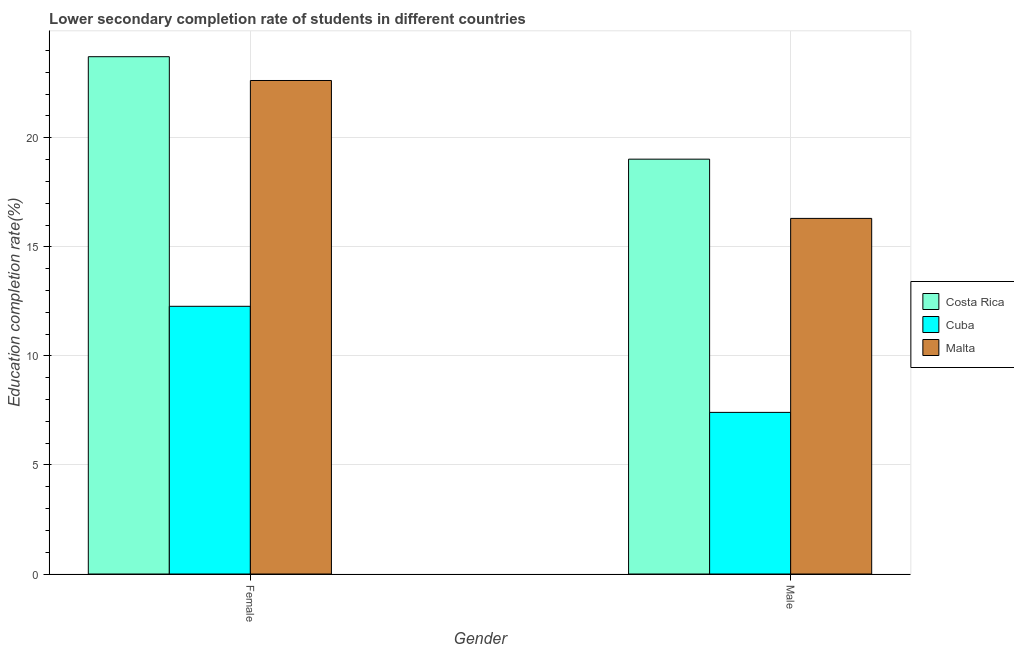Are the number of bars on each tick of the X-axis equal?
Give a very brief answer. Yes. How many bars are there on the 2nd tick from the left?
Provide a short and direct response. 3. How many bars are there on the 1st tick from the right?
Your answer should be very brief. 3. What is the education completion rate of female students in Malta?
Your answer should be compact. 22.63. Across all countries, what is the maximum education completion rate of female students?
Ensure brevity in your answer.  23.72. Across all countries, what is the minimum education completion rate of female students?
Give a very brief answer. 12.27. In which country was the education completion rate of female students minimum?
Your response must be concise. Cuba. What is the total education completion rate of female students in the graph?
Provide a short and direct response. 58.61. What is the difference between the education completion rate of male students in Malta and that in Cuba?
Provide a short and direct response. 8.89. What is the difference between the education completion rate of female students in Cuba and the education completion rate of male students in Malta?
Offer a very short reply. -4.03. What is the average education completion rate of male students per country?
Your answer should be very brief. 14.24. What is the difference between the education completion rate of male students and education completion rate of female students in Malta?
Ensure brevity in your answer.  -6.32. In how many countries, is the education completion rate of female students greater than 19 %?
Offer a very short reply. 2. What is the ratio of the education completion rate of male students in Malta to that in Cuba?
Offer a very short reply. 2.2. Is the education completion rate of female students in Malta less than that in Costa Rica?
Your answer should be compact. Yes. In how many countries, is the education completion rate of female students greater than the average education completion rate of female students taken over all countries?
Make the answer very short. 2. What does the 2nd bar from the right in Female represents?
Provide a short and direct response. Cuba. Are all the bars in the graph horizontal?
Make the answer very short. No. How many countries are there in the graph?
Ensure brevity in your answer.  3. What is the difference between two consecutive major ticks on the Y-axis?
Make the answer very short. 5. Does the graph contain grids?
Give a very brief answer. Yes. Where does the legend appear in the graph?
Your response must be concise. Center right. How are the legend labels stacked?
Provide a succinct answer. Vertical. What is the title of the graph?
Your answer should be compact. Lower secondary completion rate of students in different countries. What is the label or title of the X-axis?
Offer a very short reply. Gender. What is the label or title of the Y-axis?
Give a very brief answer. Education completion rate(%). What is the Education completion rate(%) of Costa Rica in Female?
Keep it short and to the point. 23.72. What is the Education completion rate(%) of Cuba in Female?
Your answer should be very brief. 12.27. What is the Education completion rate(%) of Malta in Female?
Provide a succinct answer. 22.63. What is the Education completion rate(%) in Costa Rica in Male?
Your answer should be very brief. 19.02. What is the Education completion rate(%) in Cuba in Male?
Your response must be concise. 7.41. What is the Education completion rate(%) of Malta in Male?
Ensure brevity in your answer.  16.3. Across all Gender, what is the maximum Education completion rate(%) of Costa Rica?
Keep it short and to the point. 23.72. Across all Gender, what is the maximum Education completion rate(%) in Cuba?
Your response must be concise. 12.27. Across all Gender, what is the maximum Education completion rate(%) of Malta?
Ensure brevity in your answer.  22.63. Across all Gender, what is the minimum Education completion rate(%) in Costa Rica?
Make the answer very short. 19.02. Across all Gender, what is the minimum Education completion rate(%) in Cuba?
Provide a short and direct response. 7.41. Across all Gender, what is the minimum Education completion rate(%) of Malta?
Provide a succinct answer. 16.3. What is the total Education completion rate(%) of Costa Rica in the graph?
Provide a short and direct response. 42.73. What is the total Education completion rate(%) in Cuba in the graph?
Keep it short and to the point. 19.68. What is the total Education completion rate(%) in Malta in the graph?
Your answer should be compact. 38.93. What is the difference between the Education completion rate(%) in Costa Rica in Female and that in Male?
Offer a very short reply. 4.7. What is the difference between the Education completion rate(%) of Cuba in Female and that in Male?
Your answer should be compact. 4.86. What is the difference between the Education completion rate(%) in Malta in Female and that in Male?
Your answer should be very brief. 6.32. What is the difference between the Education completion rate(%) of Costa Rica in Female and the Education completion rate(%) of Cuba in Male?
Offer a very short reply. 16.31. What is the difference between the Education completion rate(%) of Costa Rica in Female and the Education completion rate(%) of Malta in Male?
Your response must be concise. 7.41. What is the difference between the Education completion rate(%) of Cuba in Female and the Education completion rate(%) of Malta in Male?
Provide a succinct answer. -4.03. What is the average Education completion rate(%) of Costa Rica per Gender?
Provide a succinct answer. 21.37. What is the average Education completion rate(%) of Cuba per Gender?
Make the answer very short. 9.84. What is the average Education completion rate(%) in Malta per Gender?
Your answer should be very brief. 19.46. What is the difference between the Education completion rate(%) in Costa Rica and Education completion rate(%) in Cuba in Female?
Offer a very short reply. 11.44. What is the difference between the Education completion rate(%) of Costa Rica and Education completion rate(%) of Malta in Female?
Your answer should be compact. 1.09. What is the difference between the Education completion rate(%) of Cuba and Education completion rate(%) of Malta in Female?
Keep it short and to the point. -10.35. What is the difference between the Education completion rate(%) in Costa Rica and Education completion rate(%) in Cuba in Male?
Provide a succinct answer. 11.61. What is the difference between the Education completion rate(%) of Costa Rica and Education completion rate(%) of Malta in Male?
Your response must be concise. 2.71. What is the difference between the Education completion rate(%) of Cuba and Education completion rate(%) of Malta in Male?
Offer a very short reply. -8.89. What is the ratio of the Education completion rate(%) in Costa Rica in Female to that in Male?
Make the answer very short. 1.25. What is the ratio of the Education completion rate(%) of Cuba in Female to that in Male?
Offer a very short reply. 1.66. What is the ratio of the Education completion rate(%) of Malta in Female to that in Male?
Make the answer very short. 1.39. What is the difference between the highest and the second highest Education completion rate(%) in Costa Rica?
Give a very brief answer. 4.7. What is the difference between the highest and the second highest Education completion rate(%) in Cuba?
Your answer should be compact. 4.86. What is the difference between the highest and the second highest Education completion rate(%) of Malta?
Offer a very short reply. 6.32. What is the difference between the highest and the lowest Education completion rate(%) of Costa Rica?
Ensure brevity in your answer.  4.7. What is the difference between the highest and the lowest Education completion rate(%) of Cuba?
Keep it short and to the point. 4.86. What is the difference between the highest and the lowest Education completion rate(%) in Malta?
Your answer should be compact. 6.32. 